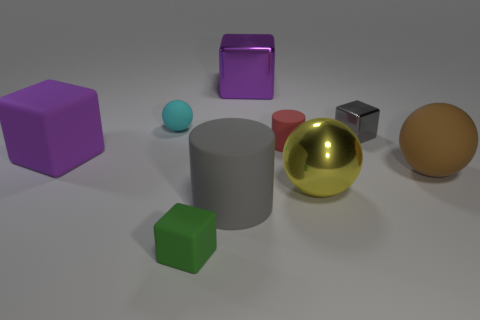There is a gray thing that is in front of the big purple object that is left of the cyan object; what is its material?
Give a very brief answer. Rubber. What size is the matte thing behind the small cube to the right of the metal thing left of the big yellow sphere?
Your answer should be very brief. Small. What number of other things are there of the same shape as the gray metallic thing?
Your answer should be compact. 3. There is a large cube that is in front of the small cylinder; is it the same color as the large shiny thing behind the tiny ball?
Offer a terse response. Yes. There is a matte cylinder that is the same size as the purple matte block; what color is it?
Ensure brevity in your answer.  Gray. Is there a tiny metallic block that has the same color as the large matte cylinder?
Your answer should be compact. Yes. There is a purple block to the left of the green thing; is its size the same as the red thing?
Provide a succinct answer. No. Are there the same number of gray cubes in front of the brown rubber object and blue shiny blocks?
Offer a very short reply. Yes. How many things are big objects that are behind the big rubber cube or green matte blocks?
Your answer should be compact. 2. There is a small thing that is both to the left of the big shiny block and in front of the small gray cube; what is its shape?
Your answer should be very brief. Cube. 